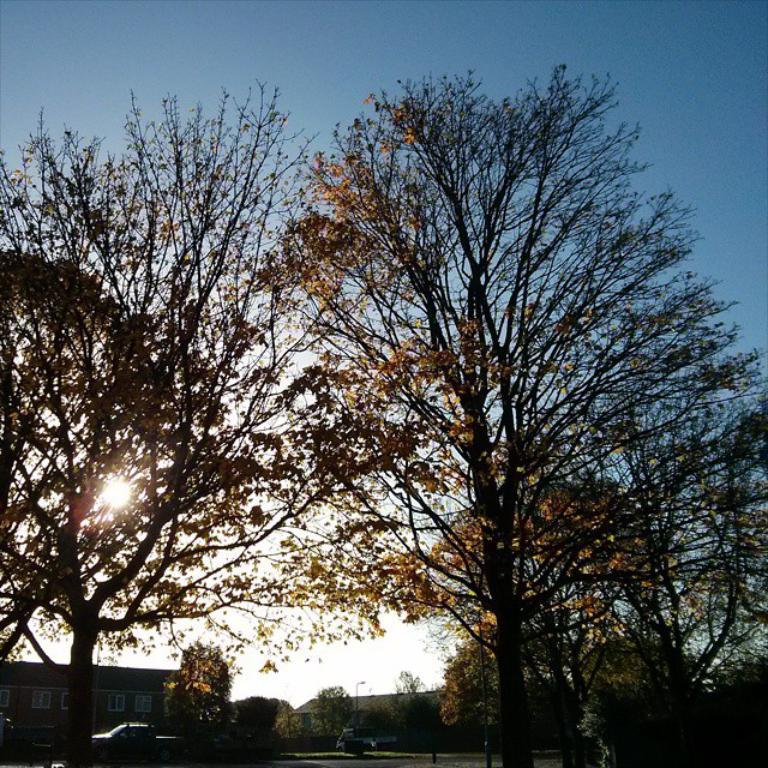What type of vegetation can be seen in the front of the image? There are trees in the front of the image. What can be found in the center of the image? There are vehicles and trees in the center of the image. What type of structures are visible in the background of the image? There are buildings in the background of the image. What is visible in the sky in the image? The sun is visible in the sky. What type of treatment is being administered in the image? There is no indication of any treatment being administered in the image. What type of learning is taking place in the image? There is no indication of any learning taking place in the image. 